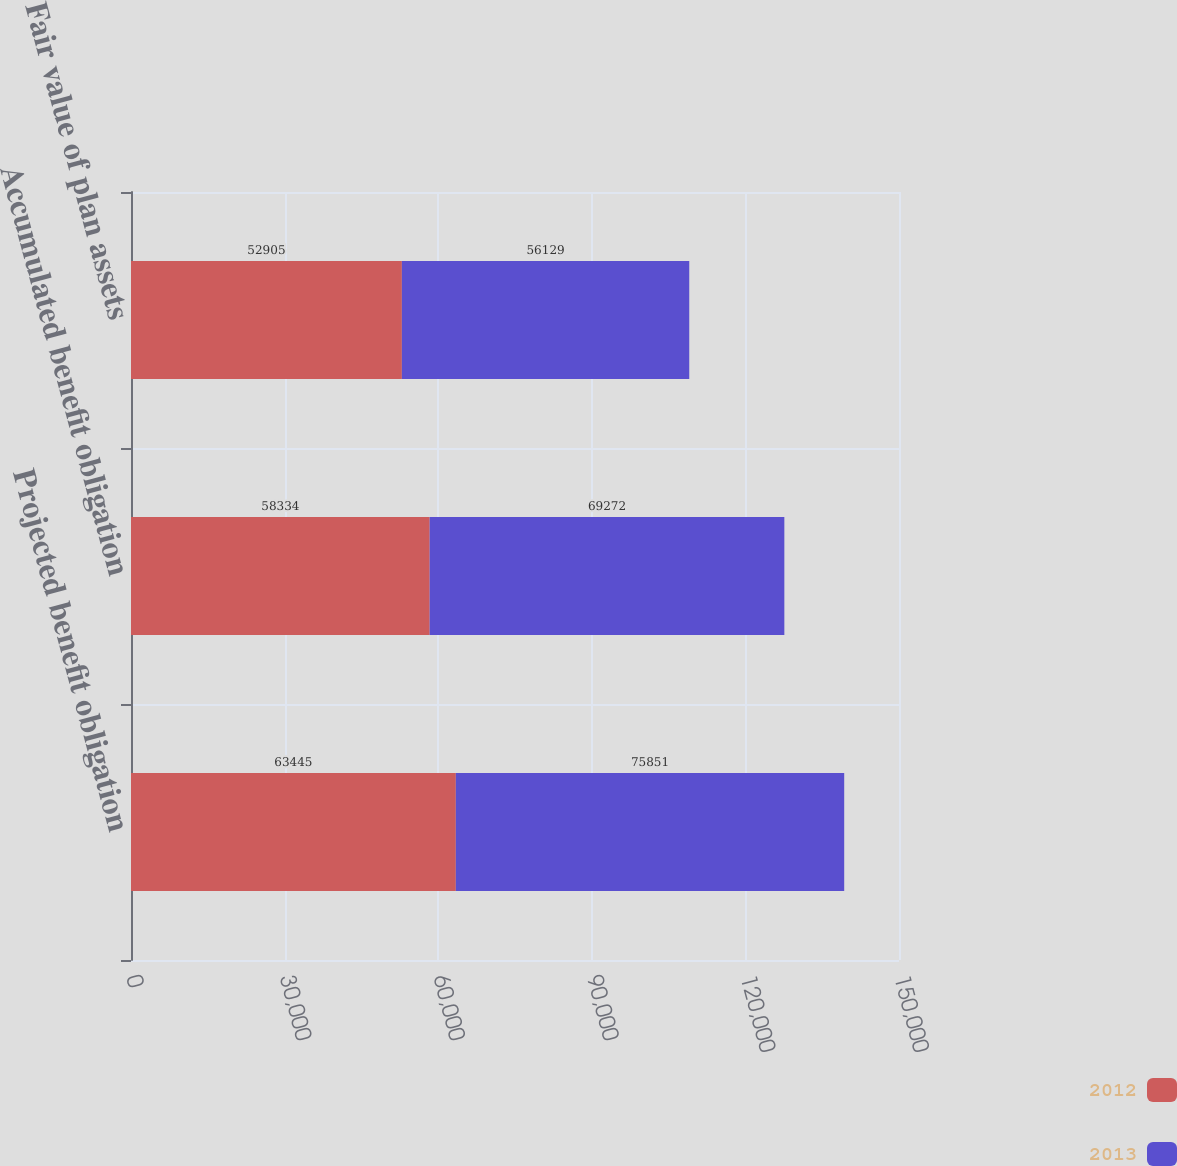<chart> <loc_0><loc_0><loc_500><loc_500><stacked_bar_chart><ecel><fcel>Projected benefit obligation<fcel>Accumulated benefit obligation<fcel>Fair value of plan assets<nl><fcel>2012<fcel>63445<fcel>58334<fcel>52905<nl><fcel>2013<fcel>75851<fcel>69272<fcel>56129<nl></chart> 